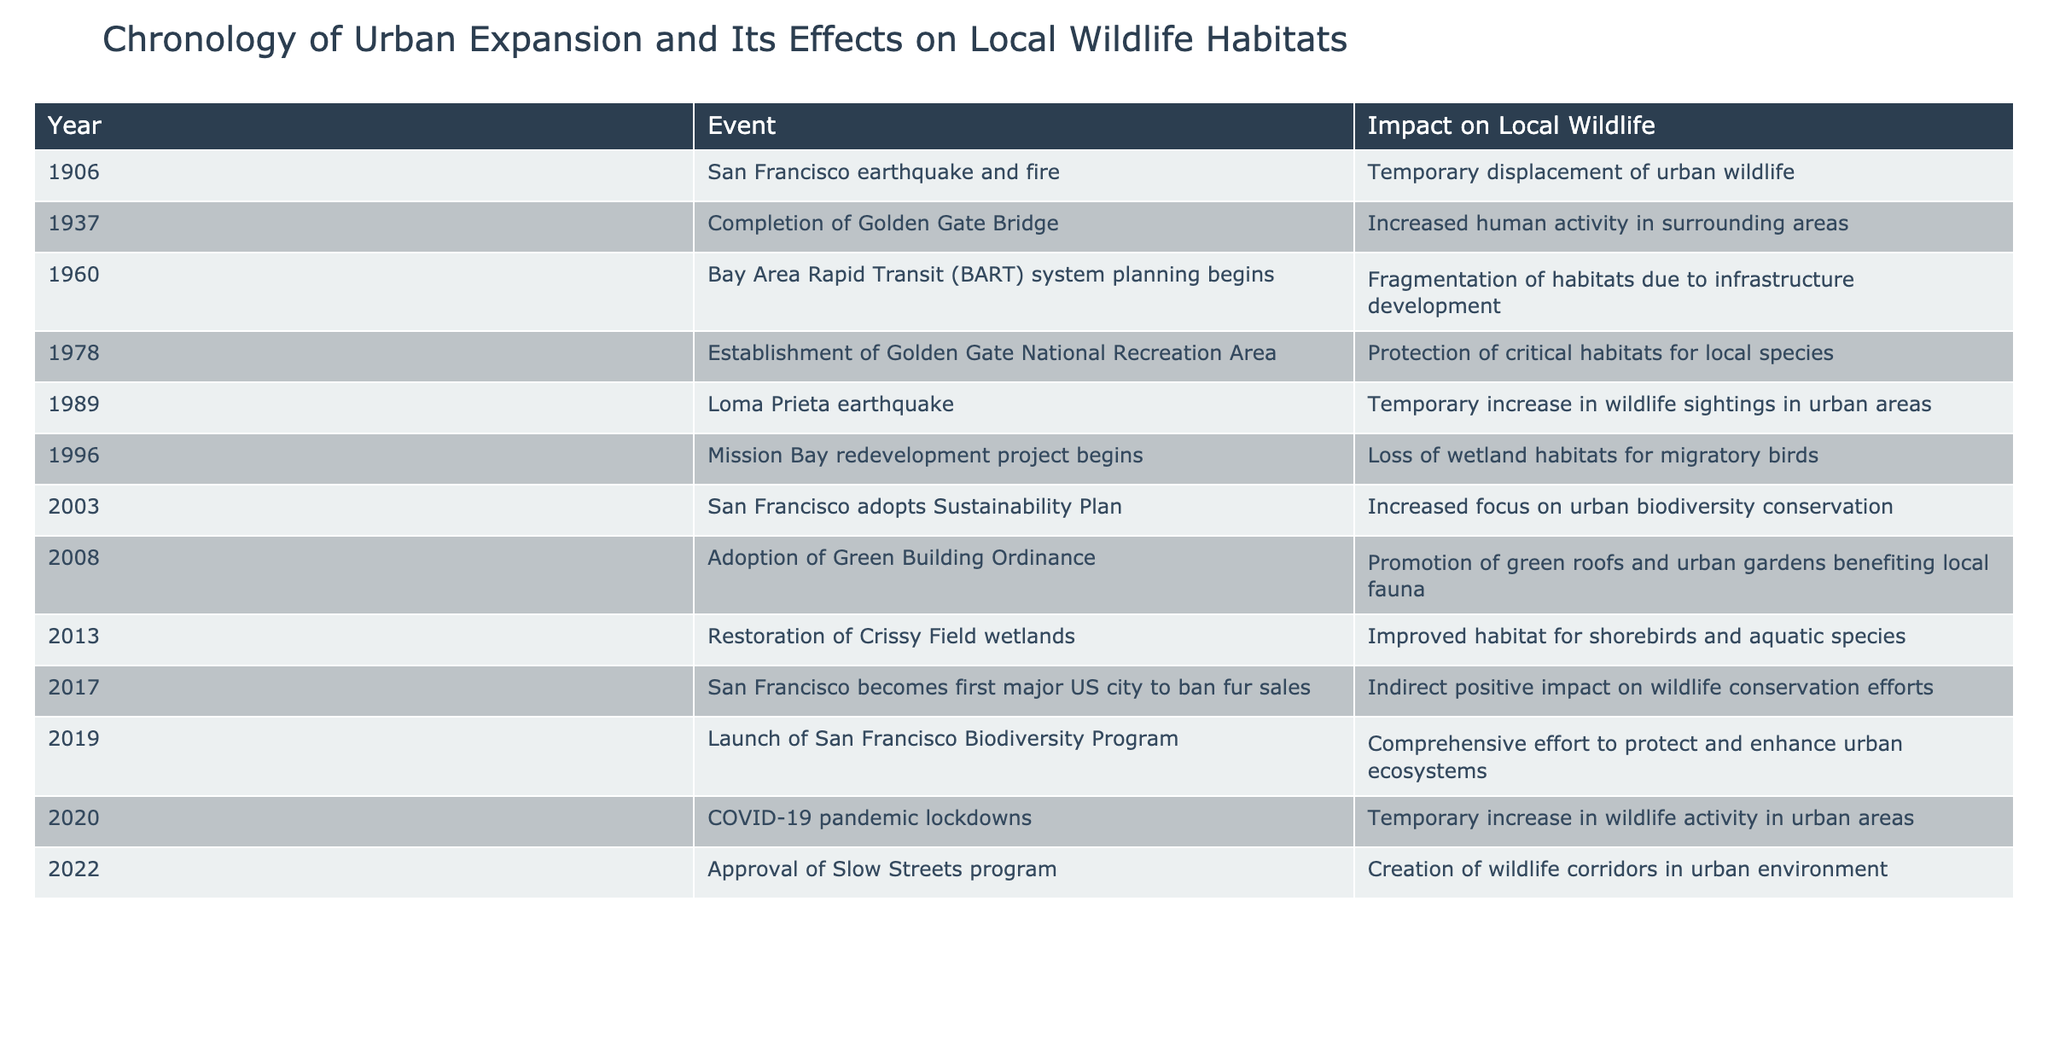What year did the establishment of the Golden Gate National Recreation Area occur? The table lists the event "Establishment of Golden Gate National Recreation Area" in the year 1978, which directly answers the question.
Answer: 1978 What impact did the adoption of the Green Building Ordinance have on local wildlife? According to the table, the adoption of the Green Building Ordinance in 2008 promoted green roofs and urban gardens, which benefited local fauna.
Answer: Promotion of green roofs and urban gardens benefiting local fauna How many significant events in this timeline occurred after the year 2000? By reviewing the table, the events after the year 2000 are from 2003 to 2022, which gives a total of 9 events (2003, 2008, 2013, 2017, 2019, 2020, and 2022).
Answer: 9 Did the COVID-19 pandemic lockdowns lead to a positive or negative impact on local wildlife? The table states that the COVID-19 pandemic lockdowns in 2020 resulted in a temporary increase in wildlife activity in urban areas, indicating a positive impact.
Answer: Yes What was the impact of the San Francisco earthquake and fire on urban wildlife? The table mentions that the San Francisco earthquake and fire in 1906 caused a temporary displacement of urban wildlife, indicating a disruption in their habitats.
Answer: Temporary displacement of urban wildlife Which event led to habitat fragmentation, and what was its year? The planning for the Bay Area Rapid Transit system began in 1960 and led to fragmentation of habitats due to infrastructure development, as per the table.
Answer: 1960, fragmentation of habitats How many events had an explicit focus on conserving or protecting local ecosystems after 2000? The events focused on conservation include the adoption of the Sustainability Plan in 2003, restoration of Crissy Field wetlands in 2013, banning fur sales in 2017, and the launch of the Biodiversity Program in 2019, resulting in 4 events.
Answer: 4 Did the completion of the Golden Gate Bridge increase or decrease human activity in the surrounding areas? According to the table, the completion of the Golden Gate Bridge in 1937 led to increased human activity in surrounding areas.
Answer: Increase in human activity What is the relationship between the establishment of the Golden Gate National Recreation Area and the Mission Bay redevelopment project? The Golden Gate National Recreation Area was established in 1978 with the goal of protecting critical habitats, whereas the Mission Bay redevelopment project began in 1996 and resulted in the loss of wetland habitats for migratory birds, suggesting a conflict between development and conservation goals.
Answer: Conflict between development and conservation 